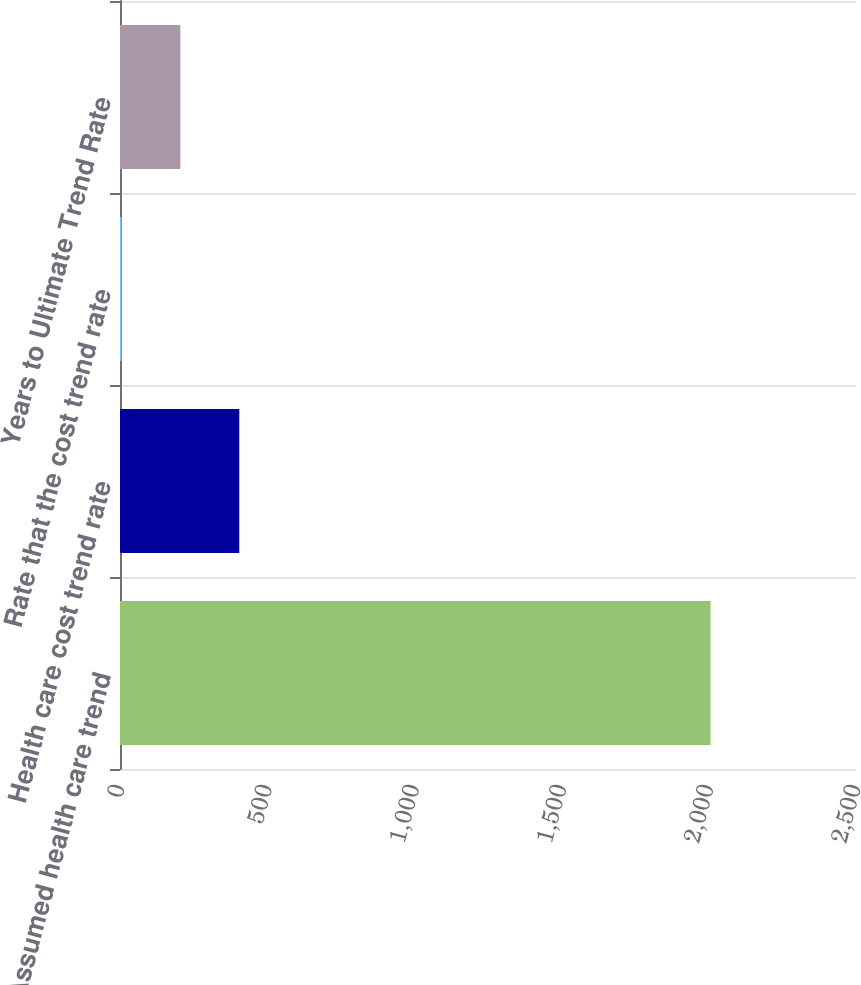<chart> <loc_0><loc_0><loc_500><loc_500><bar_chart><fcel>Assumed health care trend<fcel>Health care cost trend rate<fcel>Rate that the cost trend rate<fcel>Years to Ultimate Trend Rate<nl><fcel>2006<fcel>405.2<fcel>5<fcel>205.1<nl></chart> 